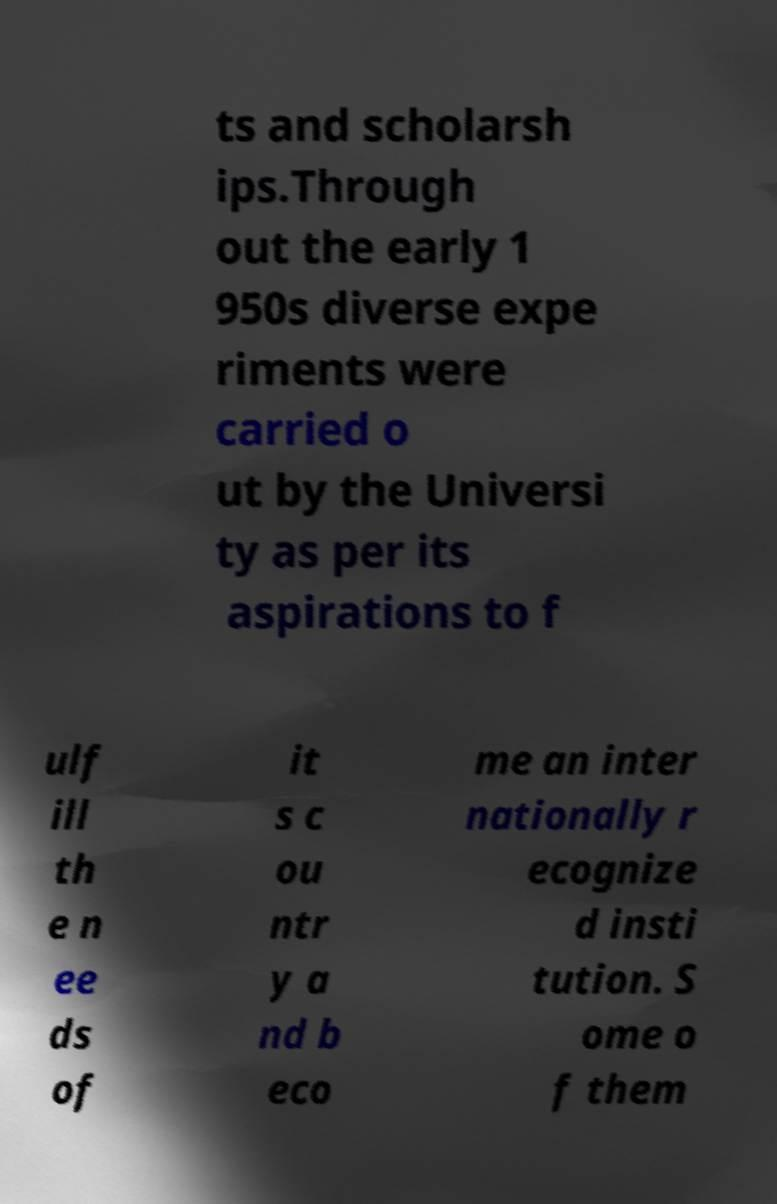Please identify and transcribe the text found in this image. ts and scholarsh ips.Through out the early 1 950s diverse expe riments were carried o ut by the Universi ty as per its aspirations to f ulf ill th e n ee ds of it s c ou ntr y a nd b eco me an inter nationally r ecognize d insti tution. S ome o f them 